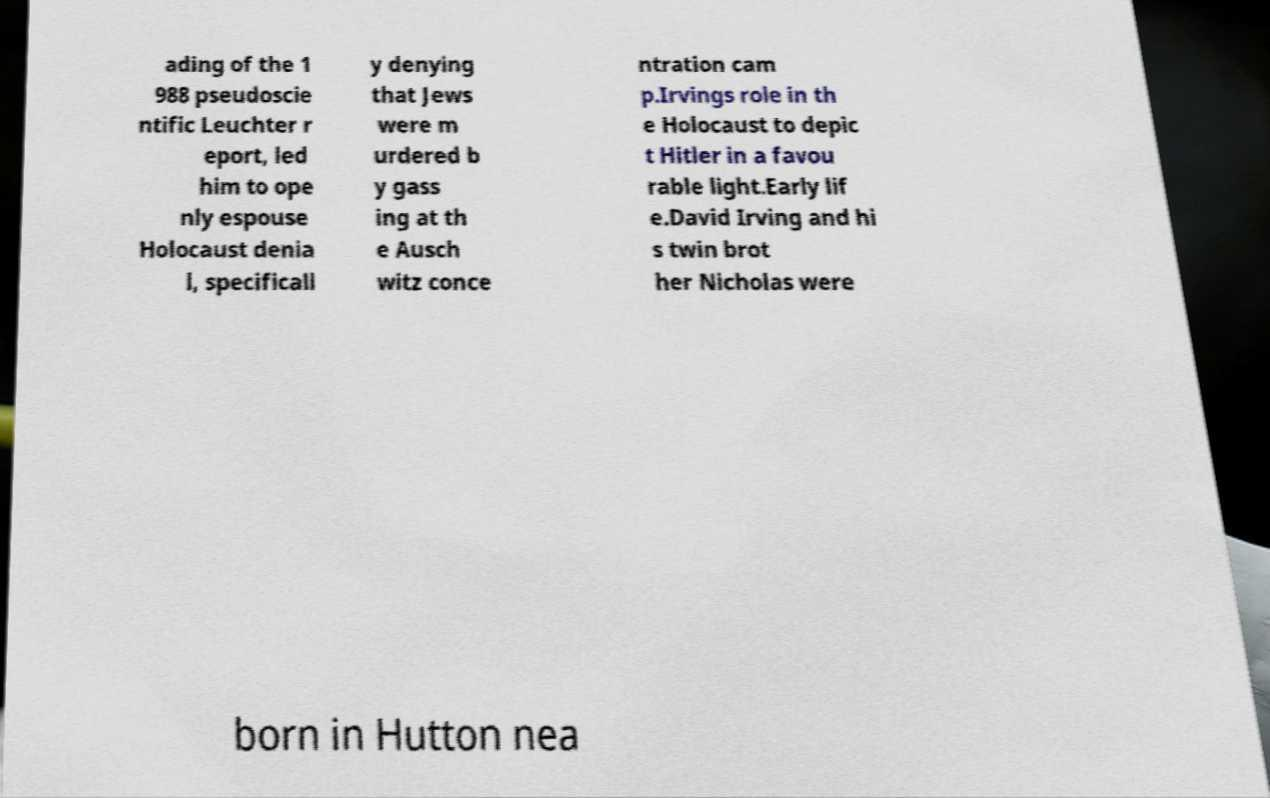Could you assist in decoding the text presented in this image and type it out clearly? ading of the 1 988 pseudoscie ntific Leuchter r eport, led him to ope nly espouse Holocaust denia l, specificall y denying that Jews were m urdered b y gass ing at th e Ausch witz conce ntration cam p.Irvings role in th e Holocaust to depic t Hitler in a favou rable light.Early lif e.David Irving and hi s twin brot her Nicholas were born in Hutton nea 